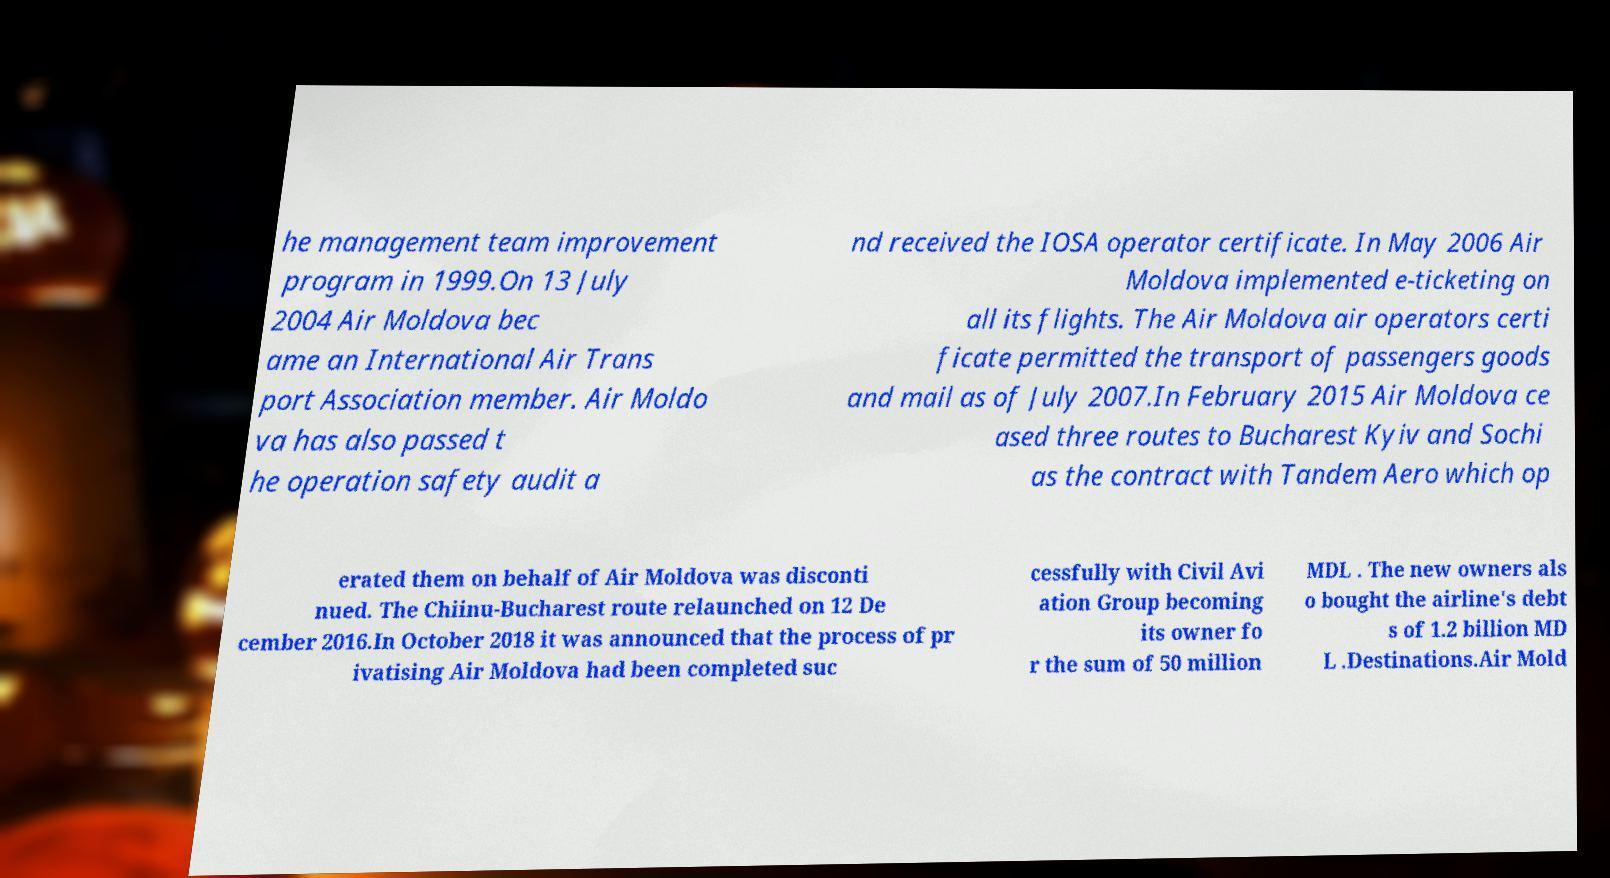What messages or text are displayed in this image? I need them in a readable, typed format. he management team improvement program in 1999.On 13 July 2004 Air Moldova bec ame an International Air Trans port Association member. Air Moldo va has also passed t he operation safety audit a nd received the IOSA operator certificate. In May 2006 Air Moldova implemented e-ticketing on all its flights. The Air Moldova air operators certi ficate permitted the transport of passengers goods and mail as of July 2007.In February 2015 Air Moldova ce ased three routes to Bucharest Kyiv and Sochi as the contract with Tandem Aero which op erated them on behalf of Air Moldova was disconti nued. The Chiinu-Bucharest route relaunched on 12 De cember 2016.In October 2018 it was announced that the process of pr ivatising Air Moldova had been completed suc cessfully with Civil Avi ation Group becoming its owner fo r the sum of 50 million MDL . The new owners als o bought the airline's debt s of 1.2 billion MD L .Destinations.Air Mold 